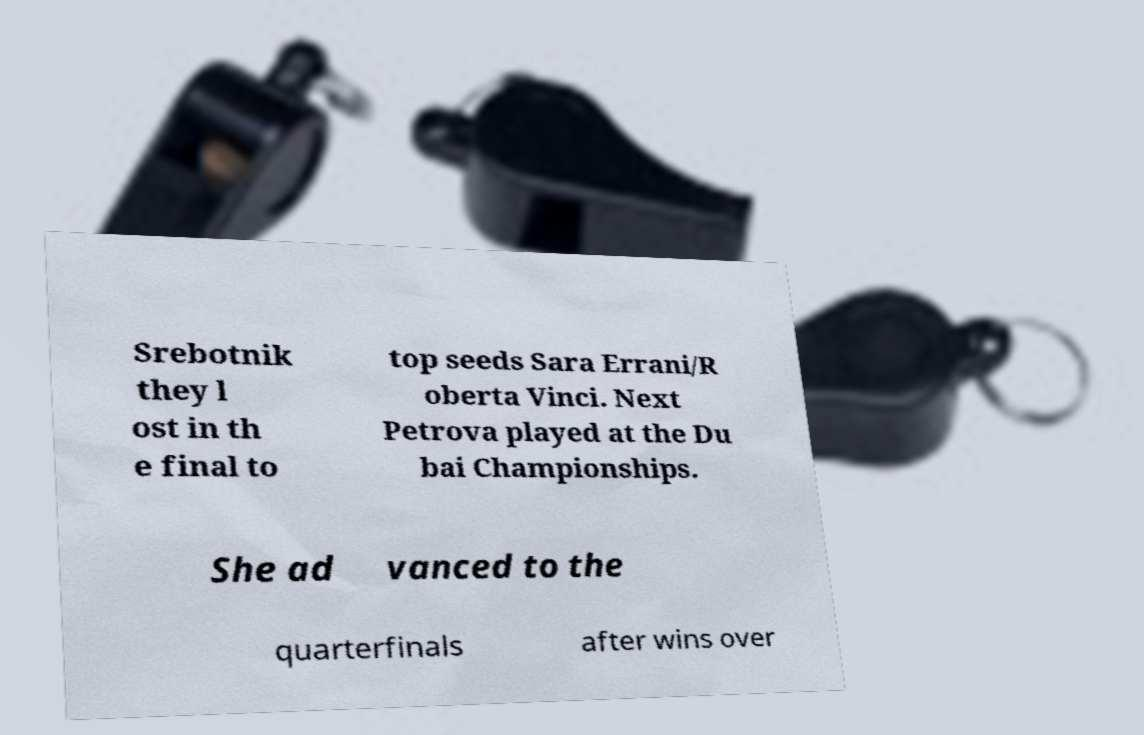What messages or text are displayed in this image? I need them in a readable, typed format. Srebotnik they l ost in th e final to top seeds Sara Errani/R oberta Vinci. Next Petrova played at the Du bai Championships. She ad vanced to the quarterfinals after wins over 